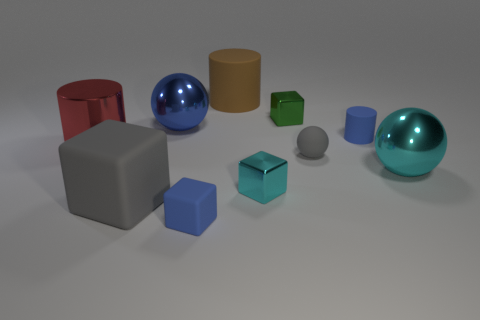Is there a brown matte thing on the right side of the big rubber thing that is on the left side of the big cylinder on the right side of the big gray cube?
Provide a short and direct response. Yes. What is the color of the small cube that is made of the same material as the large brown cylinder?
Your response must be concise. Blue. There is a matte object behind the blue cylinder; is it the same color as the big cube?
Provide a short and direct response. No. What number of cubes are small green objects or large red things?
Ensure brevity in your answer.  1. What is the size of the matte block to the left of the tiny blue object to the left of the cyan metallic cube in front of the big blue shiny ball?
Provide a short and direct response. Large. What shape is the brown rubber thing that is the same size as the blue metal object?
Provide a short and direct response. Cylinder. The small gray rubber thing has what shape?
Provide a short and direct response. Sphere. Is the block in front of the large block made of the same material as the gray sphere?
Your response must be concise. Yes. There is a shiny ball right of the blue object in front of the red shiny object; what size is it?
Your response must be concise. Large. There is a small object that is both to the left of the small gray ball and behind the rubber ball; what color is it?
Offer a terse response. Green. 